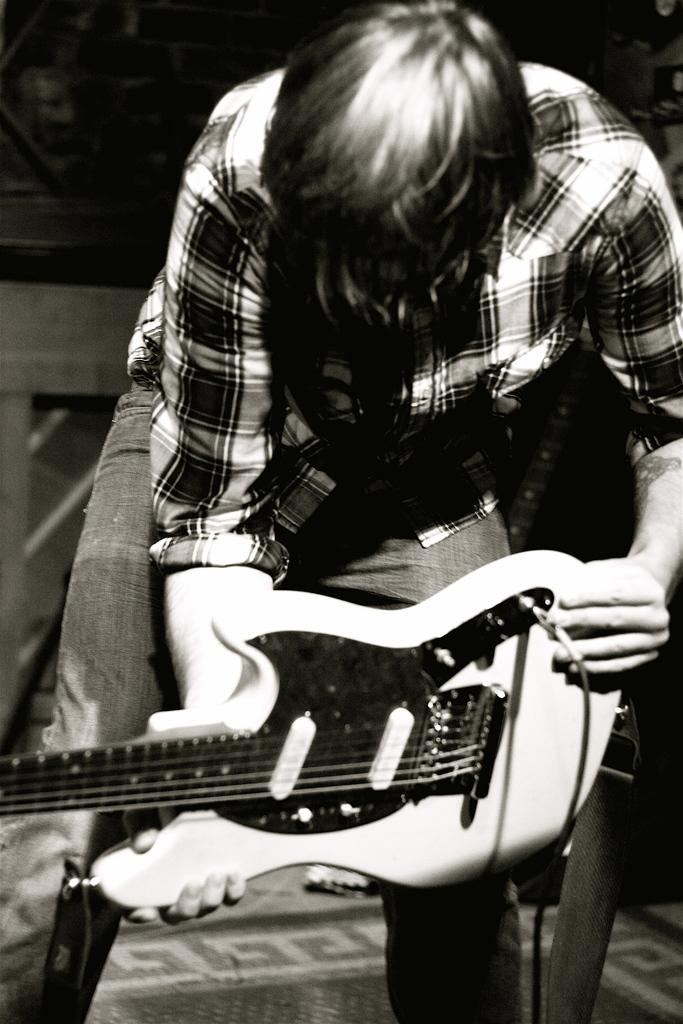What is the main subject of the image? The main subject of the image is a man. What is the man doing in the image? The man is standing in the image. What object is the man holding in his hand? The man is holding a guitar in his hand. What can be observed about the background of the image? The background of the image is dark. What type of stew is being cooked in the image? There is no stew present in the image; it features a man standing with a guitar. How many eggs are visible in the image? There are no eggs visible in the image. 